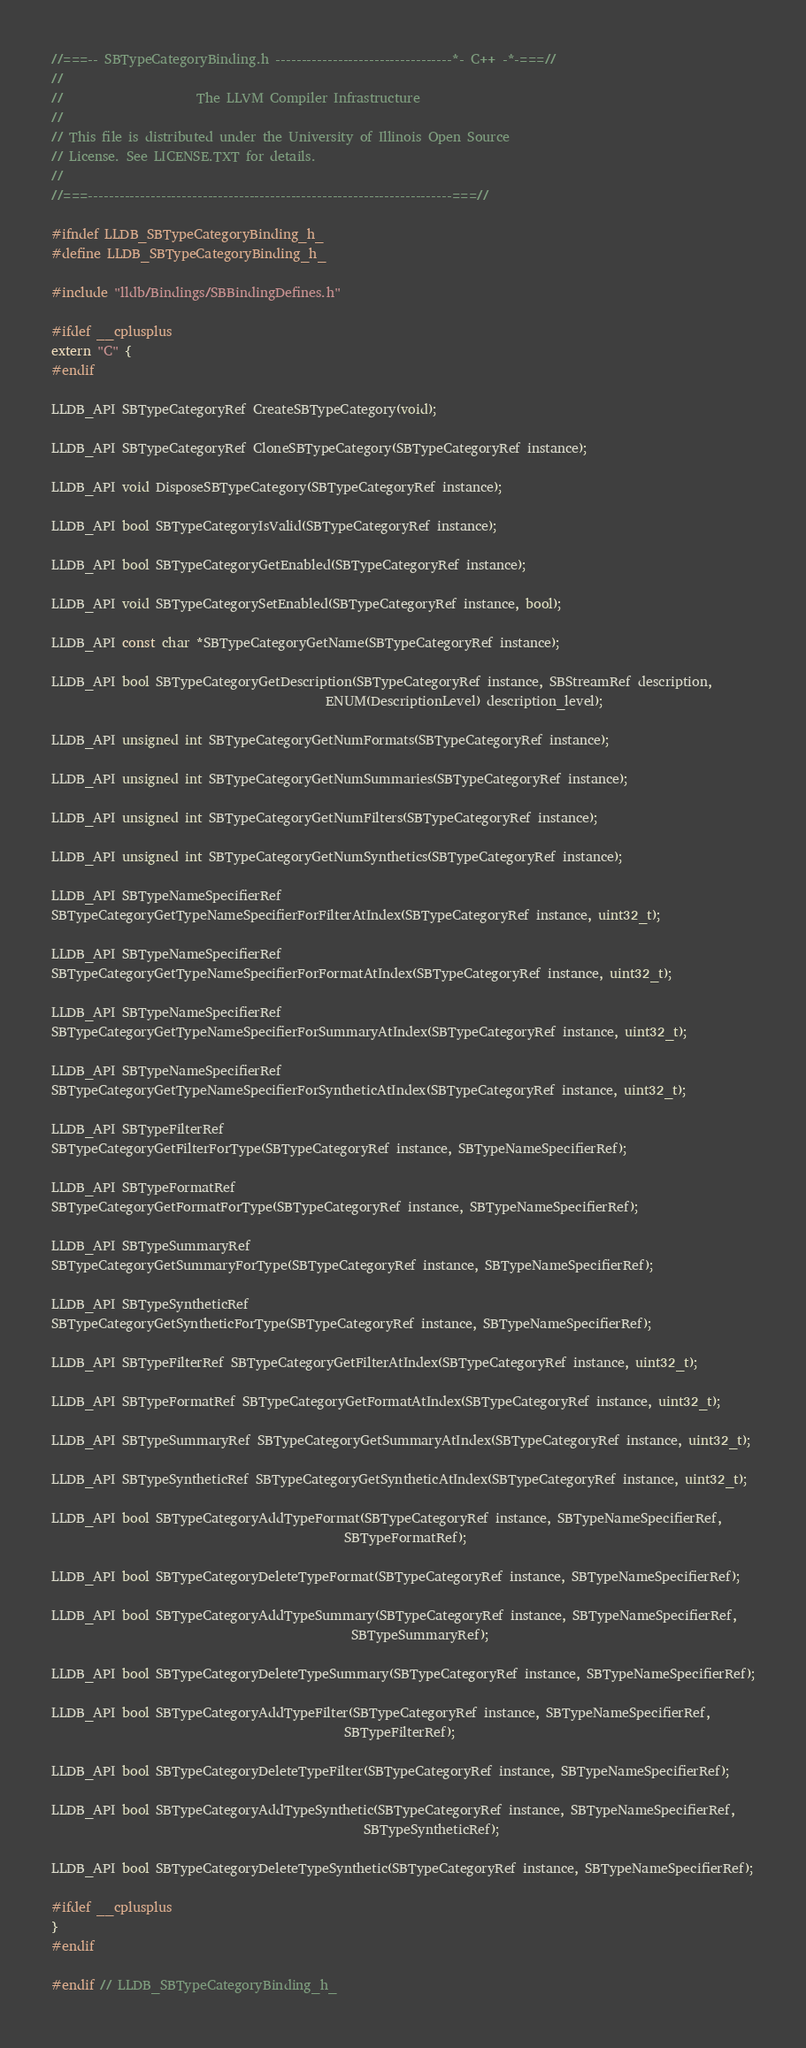Convert code to text. <code><loc_0><loc_0><loc_500><loc_500><_C_>//===-- SBTypeCategoryBinding.h ----------------------------------*- C++ -*-===//
//
//                     The LLVM Compiler Infrastructure
//
// This file is distributed under the University of Illinois Open Source
// License. See LICENSE.TXT for details.
//
//===----------------------------------------------------------------------===//

#ifndef LLDB_SBTypeCategoryBinding_h_
#define LLDB_SBTypeCategoryBinding_h_

#include "lldb/Bindings/SBBindingDefines.h"

#ifdef __cplusplus
extern "C" {
#endif

LLDB_API SBTypeCategoryRef CreateSBTypeCategory(void);

LLDB_API SBTypeCategoryRef CloneSBTypeCategory(SBTypeCategoryRef instance);

LLDB_API void DisposeSBTypeCategory(SBTypeCategoryRef instance);

LLDB_API bool SBTypeCategoryIsValid(SBTypeCategoryRef instance);

LLDB_API bool SBTypeCategoryGetEnabled(SBTypeCategoryRef instance);

LLDB_API void SBTypeCategorySetEnabled(SBTypeCategoryRef instance, bool);

LLDB_API const char *SBTypeCategoryGetName(SBTypeCategoryRef instance);

LLDB_API bool SBTypeCategoryGetDescription(SBTypeCategoryRef instance, SBStreamRef description,
                                           ENUM(DescriptionLevel) description_level);

LLDB_API unsigned int SBTypeCategoryGetNumFormats(SBTypeCategoryRef instance);

LLDB_API unsigned int SBTypeCategoryGetNumSummaries(SBTypeCategoryRef instance);

LLDB_API unsigned int SBTypeCategoryGetNumFilters(SBTypeCategoryRef instance);

LLDB_API unsigned int SBTypeCategoryGetNumSynthetics(SBTypeCategoryRef instance);

LLDB_API SBTypeNameSpecifierRef
SBTypeCategoryGetTypeNameSpecifierForFilterAtIndex(SBTypeCategoryRef instance, uint32_t);

LLDB_API SBTypeNameSpecifierRef
SBTypeCategoryGetTypeNameSpecifierForFormatAtIndex(SBTypeCategoryRef instance, uint32_t);

LLDB_API SBTypeNameSpecifierRef
SBTypeCategoryGetTypeNameSpecifierForSummaryAtIndex(SBTypeCategoryRef instance, uint32_t);

LLDB_API SBTypeNameSpecifierRef
SBTypeCategoryGetTypeNameSpecifierForSyntheticAtIndex(SBTypeCategoryRef instance, uint32_t);

LLDB_API SBTypeFilterRef
SBTypeCategoryGetFilterForType(SBTypeCategoryRef instance, SBTypeNameSpecifierRef);

LLDB_API SBTypeFormatRef
SBTypeCategoryGetFormatForType(SBTypeCategoryRef instance, SBTypeNameSpecifierRef);

LLDB_API SBTypeSummaryRef
SBTypeCategoryGetSummaryForType(SBTypeCategoryRef instance, SBTypeNameSpecifierRef);

LLDB_API SBTypeSyntheticRef
SBTypeCategoryGetSyntheticForType(SBTypeCategoryRef instance, SBTypeNameSpecifierRef);

LLDB_API SBTypeFilterRef SBTypeCategoryGetFilterAtIndex(SBTypeCategoryRef instance, uint32_t);

LLDB_API SBTypeFormatRef SBTypeCategoryGetFormatAtIndex(SBTypeCategoryRef instance, uint32_t);

LLDB_API SBTypeSummaryRef SBTypeCategoryGetSummaryAtIndex(SBTypeCategoryRef instance, uint32_t);

LLDB_API SBTypeSyntheticRef SBTypeCategoryGetSyntheticAtIndex(SBTypeCategoryRef instance, uint32_t);

LLDB_API bool SBTypeCategoryAddTypeFormat(SBTypeCategoryRef instance, SBTypeNameSpecifierRef,
                                              SBTypeFormatRef);

LLDB_API bool SBTypeCategoryDeleteTypeFormat(SBTypeCategoryRef instance, SBTypeNameSpecifierRef);

LLDB_API bool SBTypeCategoryAddTypeSummary(SBTypeCategoryRef instance, SBTypeNameSpecifierRef,
                                               SBTypeSummaryRef);

LLDB_API bool SBTypeCategoryDeleteTypeSummary(SBTypeCategoryRef instance, SBTypeNameSpecifierRef);

LLDB_API bool SBTypeCategoryAddTypeFilter(SBTypeCategoryRef instance, SBTypeNameSpecifierRef,
                                              SBTypeFilterRef);

LLDB_API bool SBTypeCategoryDeleteTypeFilter(SBTypeCategoryRef instance, SBTypeNameSpecifierRef);

LLDB_API bool SBTypeCategoryAddTypeSynthetic(SBTypeCategoryRef instance, SBTypeNameSpecifierRef,
                                                 SBTypeSyntheticRef);

LLDB_API bool SBTypeCategoryDeleteTypeSynthetic(SBTypeCategoryRef instance, SBTypeNameSpecifierRef);

#ifdef __cplusplus
}
#endif

#endif // LLDB_SBTypeCategoryBinding_h_
</code> 